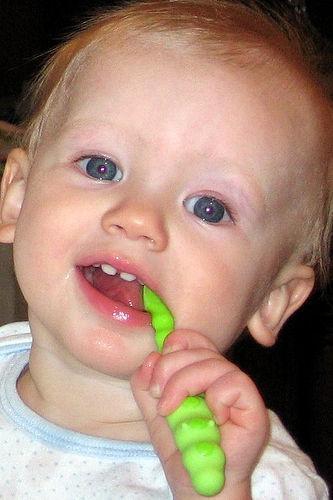How many people are there?
Give a very brief answer. 1. 